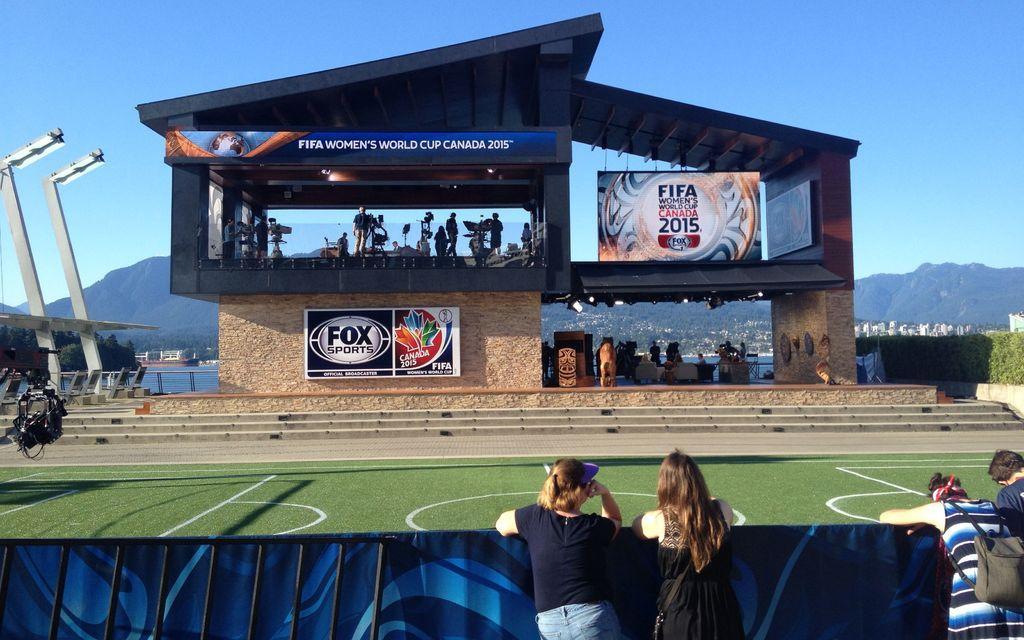Describe this image in one or two sentences. In this image we can see football ground, at the foreground of the image there are some persons leaning to the fencing and watching and at the background of the image there is a room in which there are cameramen and there are some mountains, buildings and clear sky. 